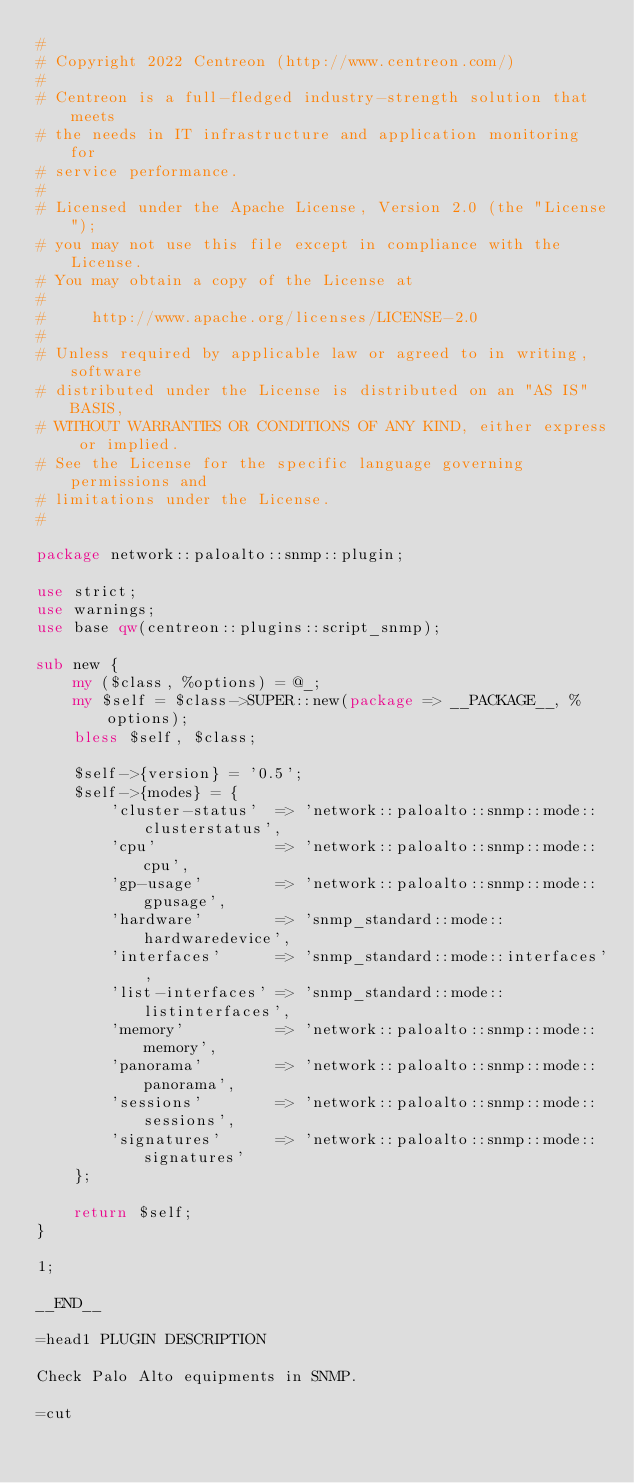<code> <loc_0><loc_0><loc_500><loc_500><_Perl_>#
# Copyright 2022 Centreon (http://www.centreon.com/)
#
# Centreon is a full-fledged industry-strength solution that meets
# the needs in IT infrastructure and application monitoring for
# service performance.
#
# Licensed under the Apache License, Version 2.0 (the "License");
# you may not use this file except in compliance with the License.
# You may obtain a copy of the License at
#
#     http://www.apache.org/licenses/LICENSE-2.0
#
# Unless required by applicable law or agreed to in writing, software
# distributed under the License is distributed on an "AS IS" BASIS,
# WITHOUT WARRANTIES OR CONDITIONS OF ANY KIND, either express or implied.
# See the License for the specific language governing permissions and
# limitations under the License.
#

package network::paloalto::snmp::plugin;

use strict;
use warnings;
use base qw(centreon::plugins::script_snmp);

sub new {
    my ($class, %options) = @_;
    my $self = $class->SUPER::new(package => __PACKAGE__, %options);
    bless $self, $class;

    $self->{version} = '0.5';
    $self->{modes} = {
        'cluster-status'  => 'network::paloalto::snmp::mode::clusterstatus',
        'cpu'             => 'network::paloalto::snmp::mode::cpu',
        'gp-usage'        => 'network::paloalto::snmp::mode::gpusage',
        'hardware'        => 'snmp_standard::mode::hardwaredevice',
        'interfaces'      => 'snmp_standard::mode::interfaces', 
        'list-interfaces' => 'snmp_standard::mode::listinterfaces',
        'memory'          => 'network::paloalto::snmp::mode::memory',
        'panorama'        => 'network::paloalto::snmp::mode::panorama',
        'sessions'        => 'network::paloalto::snmp::mode::sessions',
        'signatures'      => 'network::paloalto::snmp::mode::signatures'
    };

    return $self;
}

1;

__END__

=head1 PLUGIN DESCRIPTION

Check Palo Alto equipments in SNMP.

=cut
</code> 